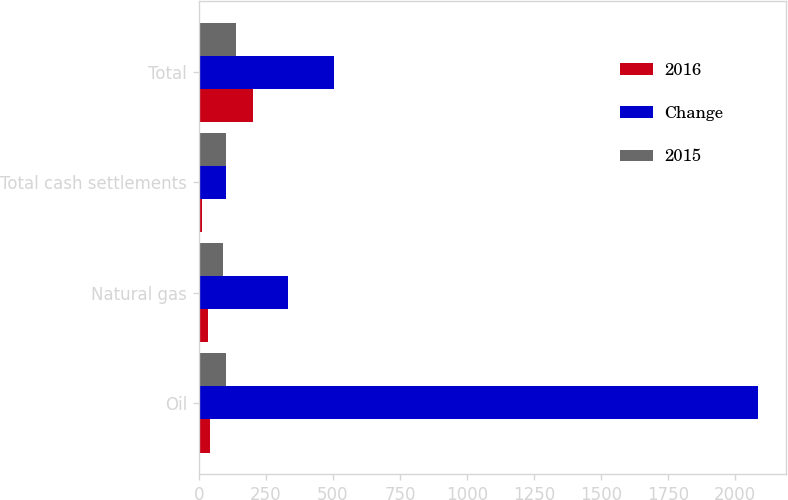Convert chart to OTSL. <chart><loc_0><loc_0><loc_500><loc_500><stacked_bar_chart><ecel><fcel>Oil<fcel>Natural gas<fcel>Total cash settlements<fcel>Total<nl><fcel>2016<fcel>41<fcel>35<fcel>11<fcel>201<nl><fcel>Change<fcel>2083<fcel>333<fcel>102<fcel>503<nl><fcel>2015<fcel>102<fcel>89<fcel>100<fcel>140<nl></chart> 